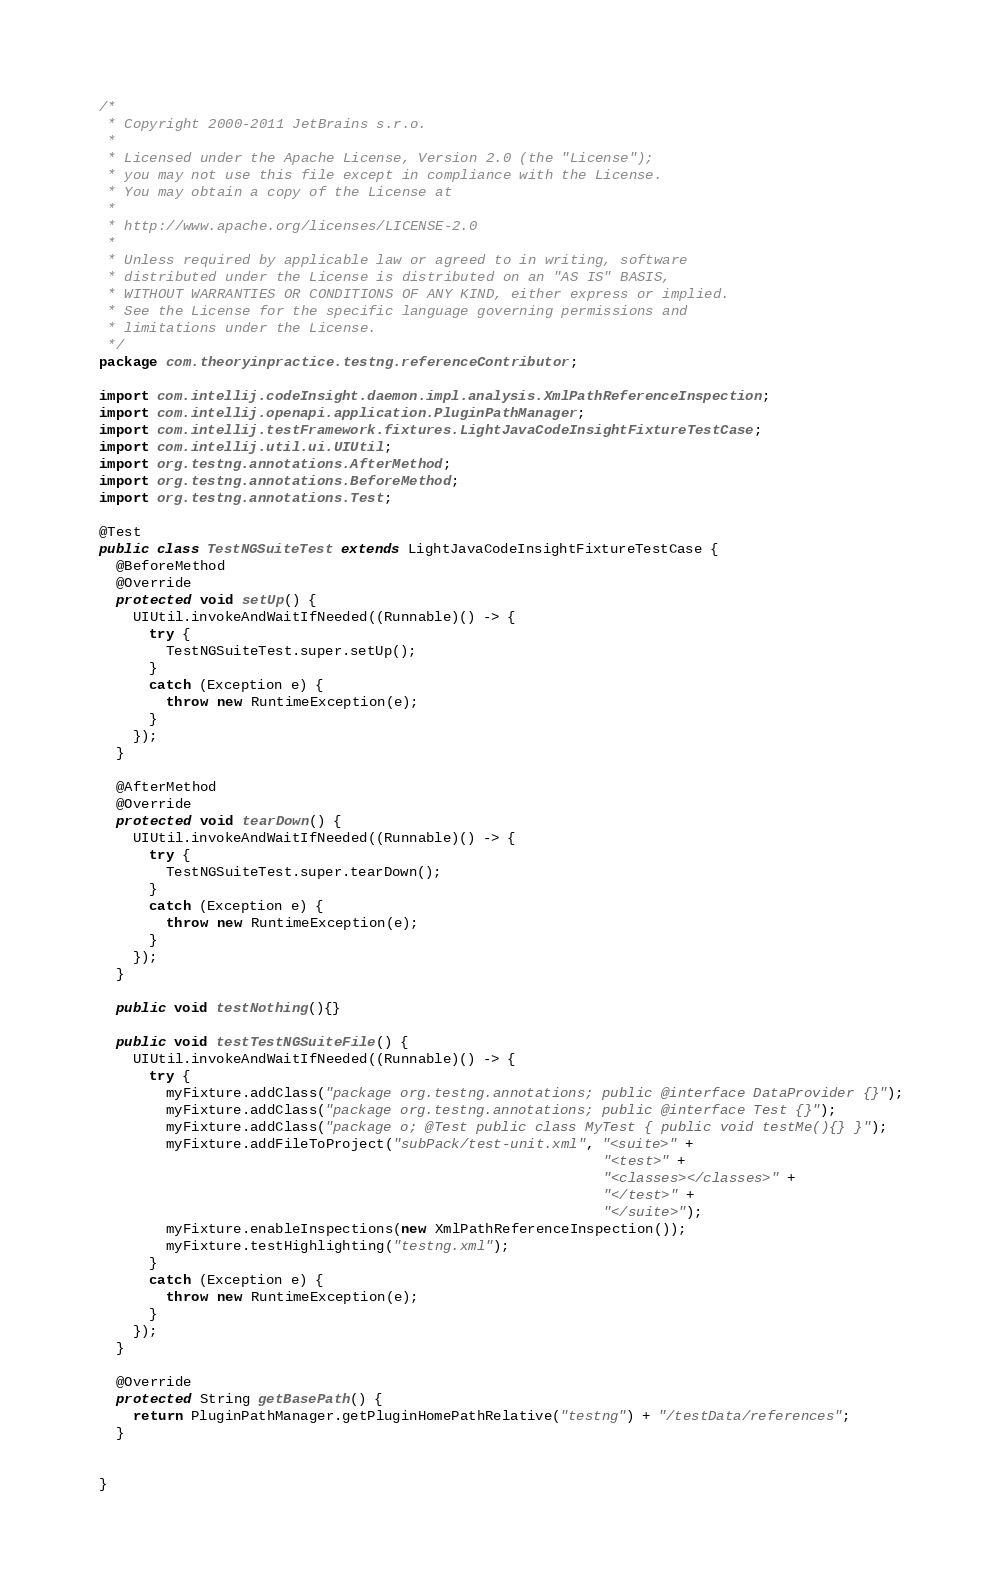<code> <loc_0><loc_0><loc_500><loc_500><_Java_>/*
 * Copyright 2000-2011 JetBrains s.r.o.
 *
 * Licensed under the Apache License, Version 2.0 (the "License");
 * you may not use this file except in compliance with the License.
 * You may obtain a copy of the License at
 *
 * http://www.apache.org/licenses/LICENSE-2.0
 *
 * Unless required by applicable law or agreed to in writing, software
 * distributed under the License is distributed on an "AS IS" BASIS,
 * WITHOUT WARRANTIES OR CONDITIONS OF ANY KIND, either express or implied.
 * See the License for the specific language governing permissions and
 * limitations under the License.
 */
package com.theoryinpractice.testng.referenceContributor;

import com.intellij.codeInsight.daemon.impl.analysis.XmlPathReferenceInspection;
import com.intellij.openapi.application.PluginPathManager;
import com.intellij.testFramework.fixtures.LightJavaCodeInsightFixtureTestCase;
import com.intellij.util.ui.UIUtil;
import org.testng.annotations.AfterMethod;
import org.testng.annotations.BeforeMethod;
import org.testng.annotations.Test;

@Test
public class TestNGSuiteTest extends LightJavaCodeInsightFixtureTestCase {
  @BeforeMethod
  @Override
  protected void setUp() {
    UIUtil.invokeAndWaitIfNeeded((Runnable)() -> {
      try {
        TestNGSuiteTest.super.setUp();
      }
      catch (Exception e) {
        throw new RuntimeException(e);
      }
    });
  }

  @AfterMethod
  @Override
  protected void tearDown() {
    UIUtil.invokeAndWaitIfNeeded((Runnable)() -> {
      try {
        TestNGSuiteTest.super.tearDown();
      }
      catch (Exception e) {
        throw new RuntimeException(e);
      }
    });
  }

  public void testNothing(){}

  public void testTestNGSuiteFile() {
    UIUtil.invokeAndWaitIfNeeded((Runnable)() -> {
      try {
        myFixture.addClass("package org.testng.annotations; public @interface DataProvider {}");
        myFixture.addClass("package org.testng.annotations; public @interface Test {}");
        myFixture.addClass("package o; @Test public class MyTest { public void testMe(){} }");
        myFixture.addFileToProject("subPack/test-unit.xml", "<suite>" +
                                                            "<test>" +
                                                            "<classes></classes>" +
                                                            "</test>" +
                                                            "</suite>");
        myFixture.enableInspections(new XmlPathReferenceInspection());
        myFixture.testHighlighting("testng.xml");
      }
      catch (Exception e) {
        throw new RuntimeException(e);
      }
    });
  }

  @Override
  protected String getBasePath() {
    return PluginPathManager.getPluginHomePathRelative("testng") + "/testData/references";
  }


}
</code> 